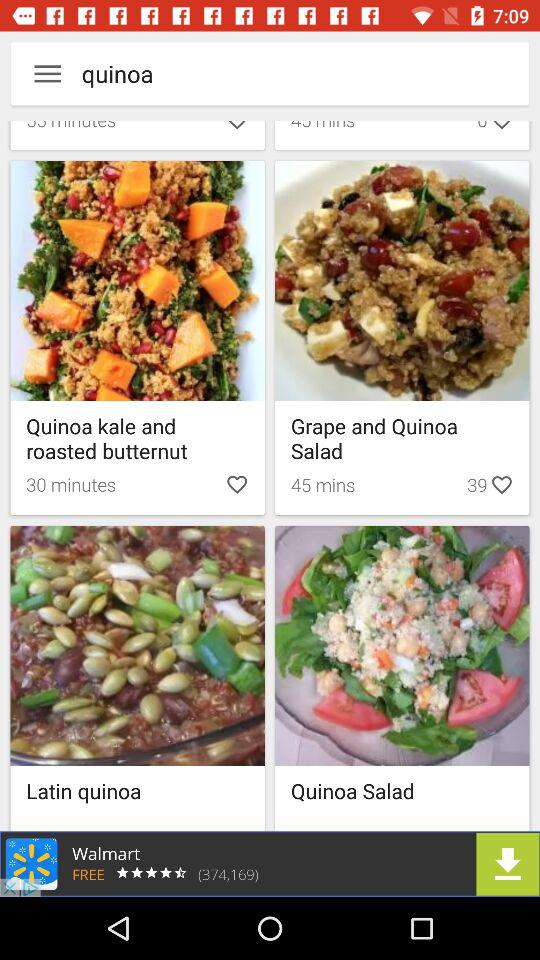How many likes are there of "Grape and Quinoa Salad"? There are 39 likes of "Grape and Quinoa Salad". 